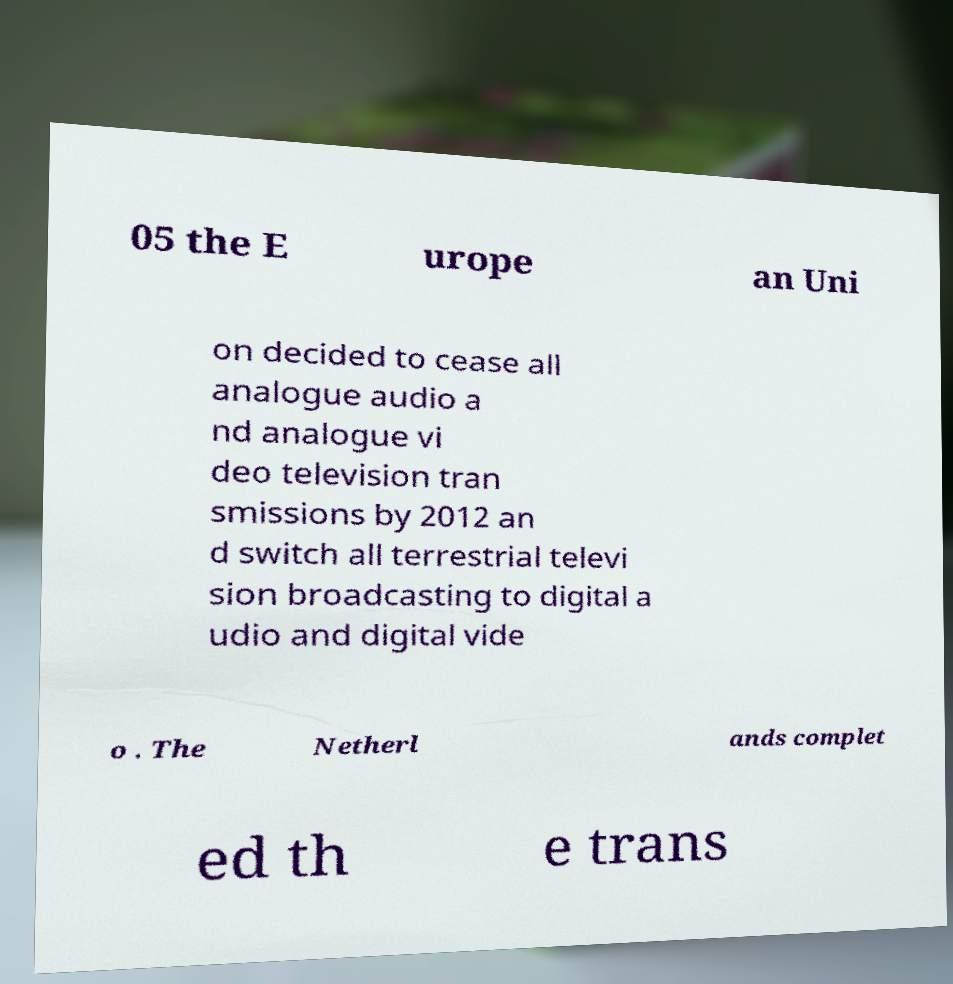Could you extract and type out the text from this image? 05 the E urope an Uni on decided to cease all analogue audio a nd analogue vi deo television tran smissions by 2012 an d switch all terrestrial televi sion broadcasting to digital a udio and digital vide o . The Netherl ands complet ed th e trans 